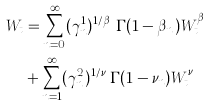<formula> <loc_0><loc_0><loc_500><loc_500>W _ { t } & = \sum _ { n = 0 } ^ { \infty } ( \gamma ^ { 1 } _ { n } ) ^ { 1 / \beta _ { n } } \Gamma ( 1 - \beta _ { n } ) W _ { t } ^ { \beta _ { n } } \\ & + \sum _ { n = 1 } ^ { \infty } ( \gamma ^ { 2 } _ { n } ) ^ { 1 / \nu _ { n } } \Gamma ( 1 - \nu _ { n } ) W _ { t } ^ { \nu _ { n } }</formula> 